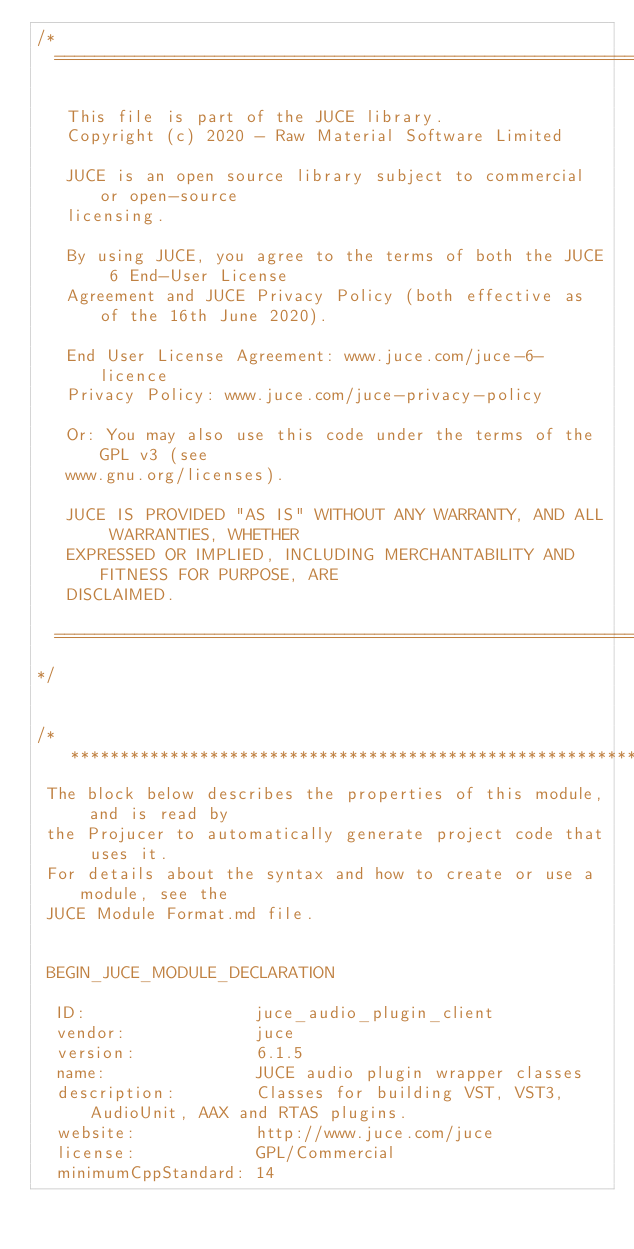<code> <loc_0><loc_0><loc_500><loc_500><_C_>/*
  ==============================================================================

   This file is part of the JUCE library.
   Copyright (c) 2020 - Raw Material Software Limited

   JUCE is an open source library subject to commercial or open-source
   licensing.

   By using JUCE, you agree to the terms of both the JUCE 6 End-User License
   Agreement and JUCE Privacy Policy (both effective as of the 16th June 2020).

   End User License Agreement: www.juce.com/juce-6-licence
   Privacy Policy: www.juce.com/juce-privacy-policy

   Or: You may also use this code under the terms of the GPL v3 (see
   www.gnu.org/licenses).

   JUCE IS PROVIDED "AS IS" WITHOUT ANY WARRANTY, AND ALL WARRANTIES, WHETHER
   EXPRESSED OR IMPLIED, INCLUDING MERCHANTABILITY AND FITNESS FOR PURPOSE, ARE
   DISCLAIMED.

  ==============================================================================
*/


/*******************************************************************************
 The block below describes the properties of this module, and is read by
 the Projucer to automatically generate project code that uses it.
 For details about the syntax and how to create or use a module, see the
 JUCE Module Format.md file.


 BEGIN_JUCE_MODULE_DECLARATION

  ID:                 juce_audio_plugin_client
  vendor:             juce
  version:            6.1.5
  name:               JUCE audio plugin wrapper classes
  description:        Classes for building VST, VST3, AudioUnit, AAX and RTAS plugins.
  website:            http://www.juce.com/juce
  license:            GPL/Commercial
  minimumCppStandard: 14
</code> 